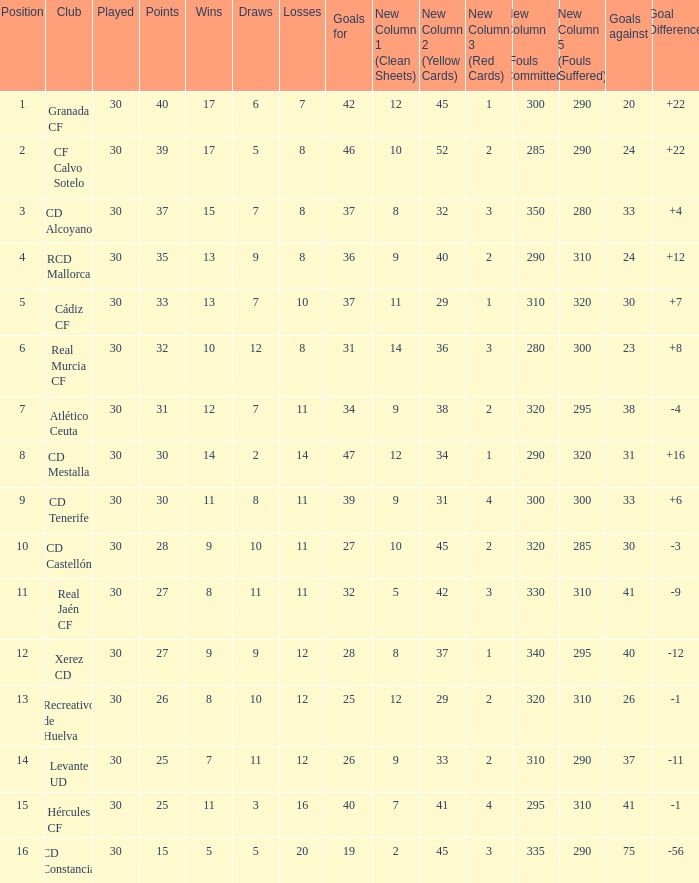Which Wins have a Goal Difference larger than 12, and a Club of granada cf, and Played larger than 30? None. 